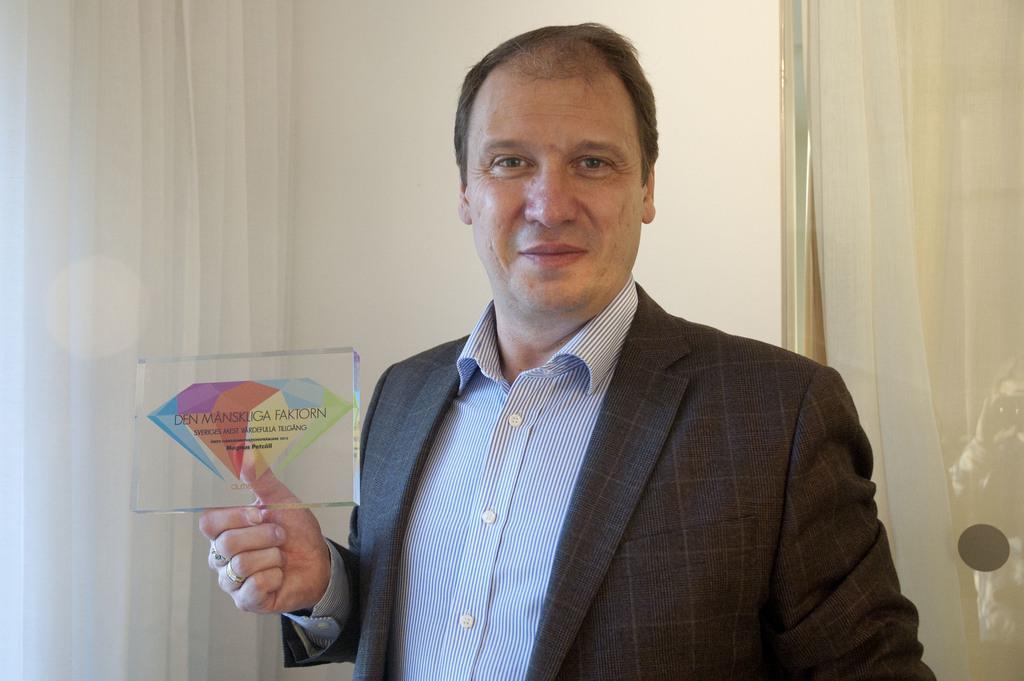Please provide a concise description of this image. In this image I can see a person holding a glass cube , on the cube I can see colorful design and text , in the background I can see the wall and curtain 